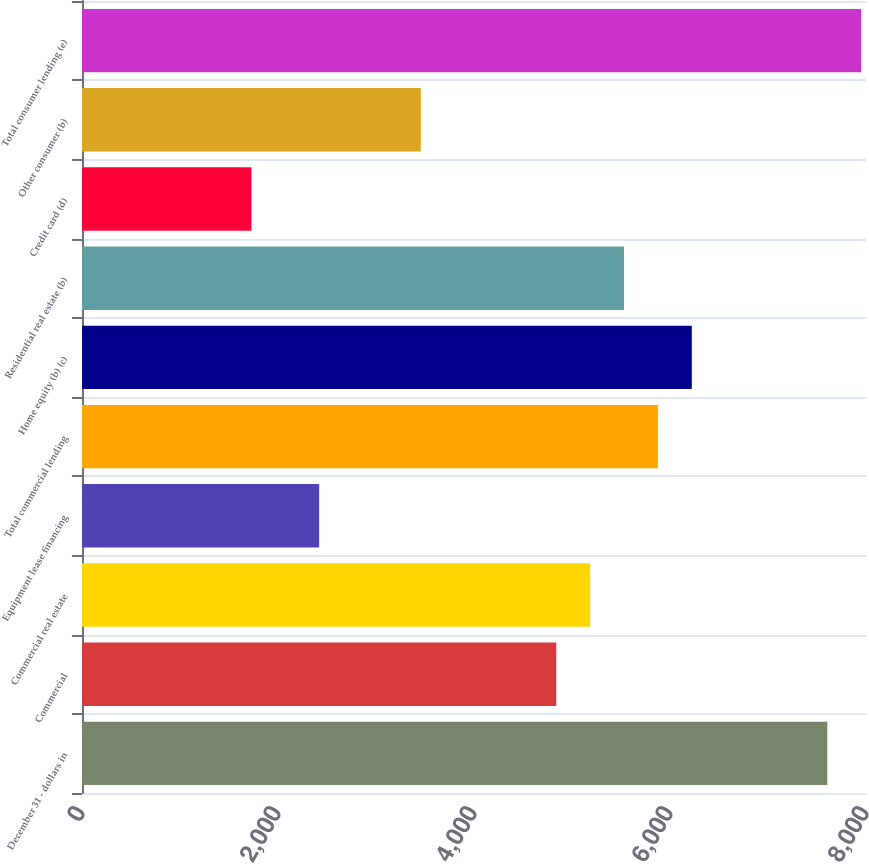Convert chart. <chart><loc_0><loc_0><loc_500><loc_500><bar_chart><fcel>December 31 - dollars in<fcel>Commercial<fcel>Commercial real estate<fcel>Equipment lease financing<fcel>Total commercial lending<fcel>Home equity (b) (c)<fcel>Residential real estate (b)<fcel>Credit card (d)<fcel>Other consumer (b)<fcel>Total consumer lending (e)<nl><fcel>7605.14<fcel>4839.7<fcel>5185.38<fcel>2419.94<fcel>5876.74<fcel>6222.42<fcel>5531.06<fcel>1728.58<fcel>3456.98<fcel>7950.82<nl></chart> 